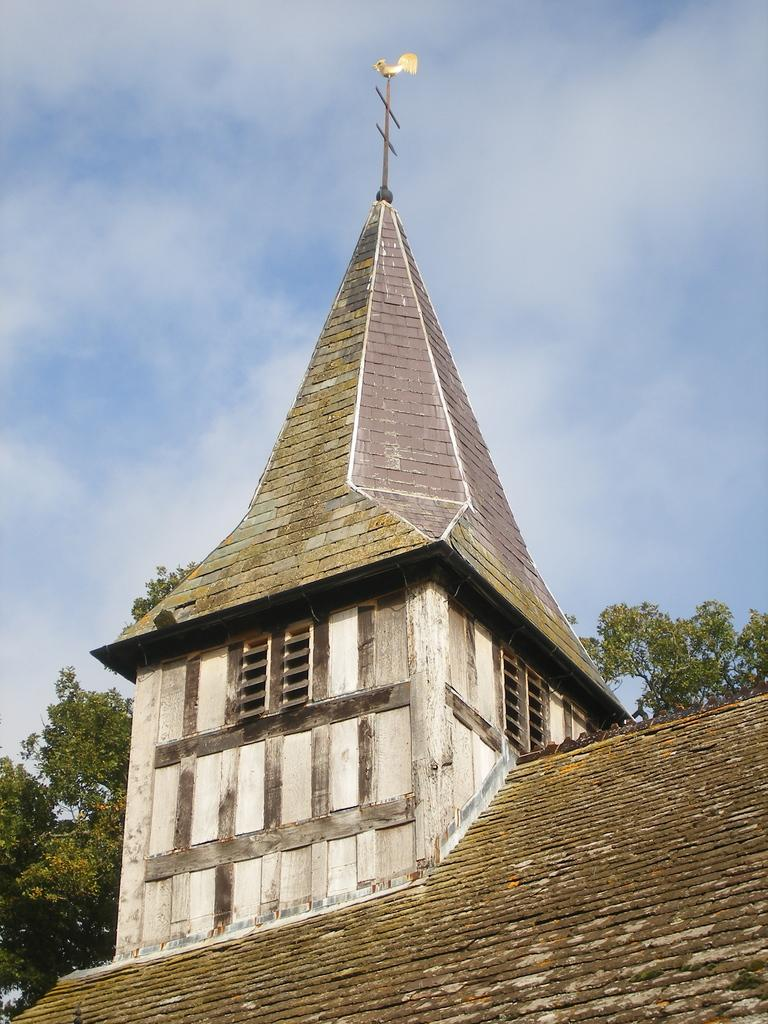What is the condition of the sky in the image? The sky is clear in the image. What structure can be seen in the image? There is a building in the image. What feature is present on the building? The building has a wind vane. What type of vegetation is visible behind the building? There are trees behind the building in the image. How many chickens are sitting on the wind vane in the image? There are no chickens present in the image, and therefore none are sitting on the wind vane. What type of money can be seen in the image? There is no money visible in the image. 